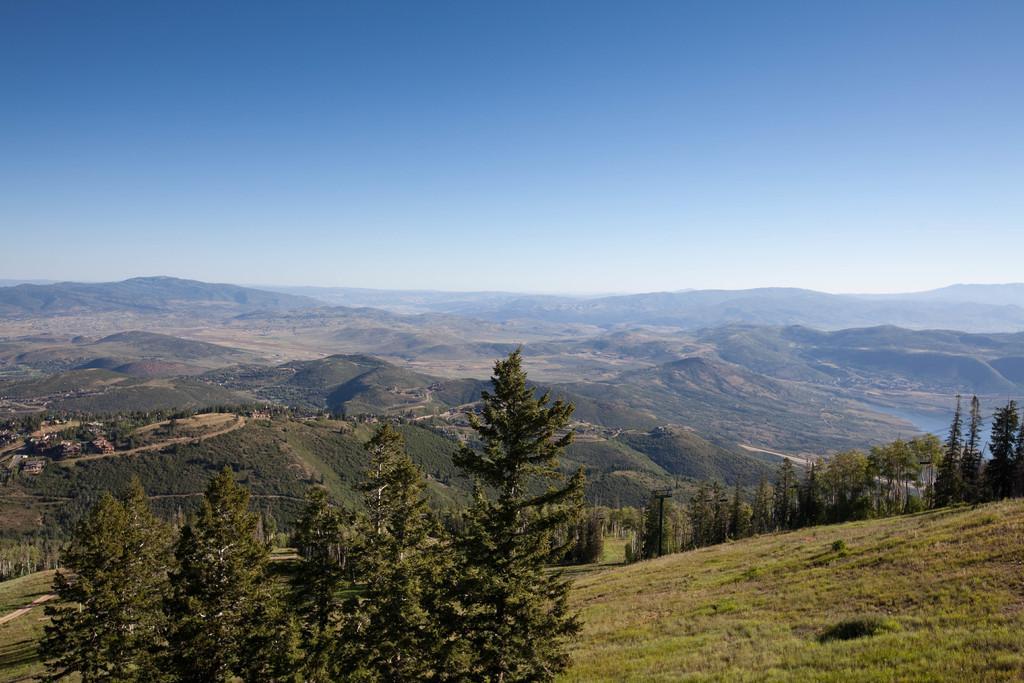Can you describe this image briefly? In the background of the image there are mountains. There are trees. At the bottom of the image there is grass. 